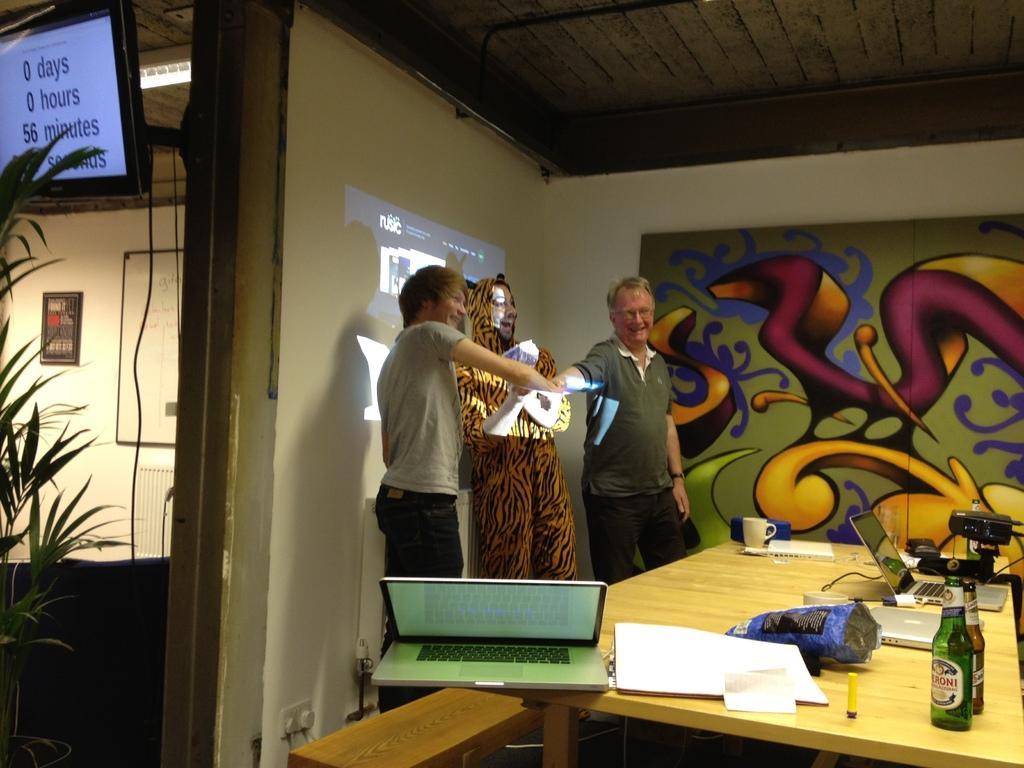Please provide a concise description of this image. In this image I can see few people are standing, I can also see smile on their faces. Here on this table I can see few bottles, few laptops and a projector. In the background I can see a television and a plant. 